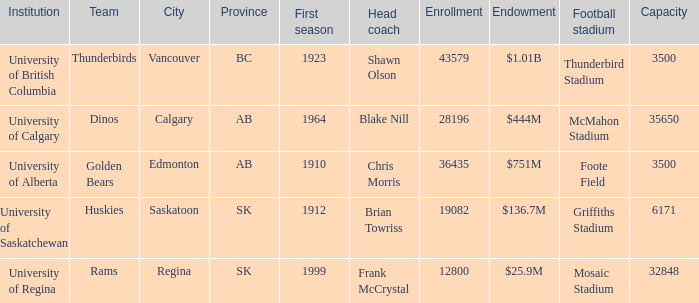What's the count of endowments mosaic stadium possesses? 1.0. 